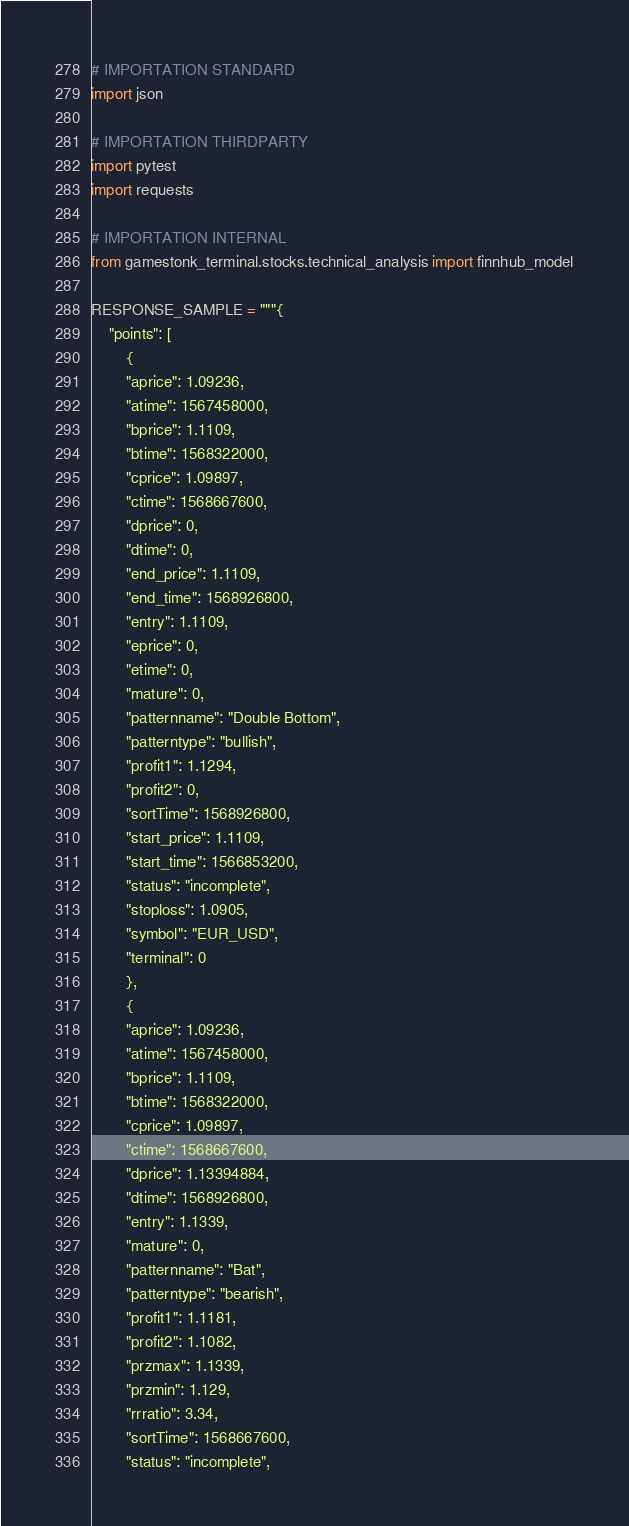<code> <loc_0><loc_0><loc_500><loc_500><_Python_># IMPORTATION STANDARD
import json

# IMPORTATION THIRDPARTY
import pytest
import requests

# IMPORTATION INTERNAL
from gamestonk_terminal.stocks.technical_analysis import finnhub_model

RESPONSE_SAMPLE = """{
    "points": [
        {
        "aprice": 1.09236,
        "atime": 1567458000,
        "bprice": 1.1109,
        "btime": 1568322000,
        "cprice": 1.09897,
        "ctime": 1568667600,
        "dprice": 0,
        "dtime": 0,
        "end_price": 1.1109,
        "end_time": 1568926800,
        "entry": 1.1109,
        "eprice": 0,
        "etime": 0,
        "mature": 0,
        "patternname": "Double Bottom",
        "patterntype": "bullish",
        "profit1": 1.1294,
        "profit2": 0,
        "sortTime": 1568926800,
        "start_price": 1.1109,
        "start_time": 1566853200,
        "status": "incomplete",
        "stoploss": 1.0905,
        "symbol": "EUR_USD",
        "terminal": 0
        },
        {
        "aprice": 1.09236,
        "atime": 1567458000,
        "bprice": 1.1109,
        "btime": 1568322000,
        "cprice": 1.09897,
        "ctime": 1568667600,
        "dprice": 1.13394884,
        "dtime": 1568926800,
        "entry": 1.1339,
        "mature": 0,
        "patternname": "Bat",
        "patterntype": "bearish",
        "profit1": 1.1181,
        "profit2": 1.1082,
        "przmax": 1.1339,
        "przmin": 1.129,
        "rrratio": 3.34,
        "sortTime": 1568667600,
        "status": "incomplete",</code> 